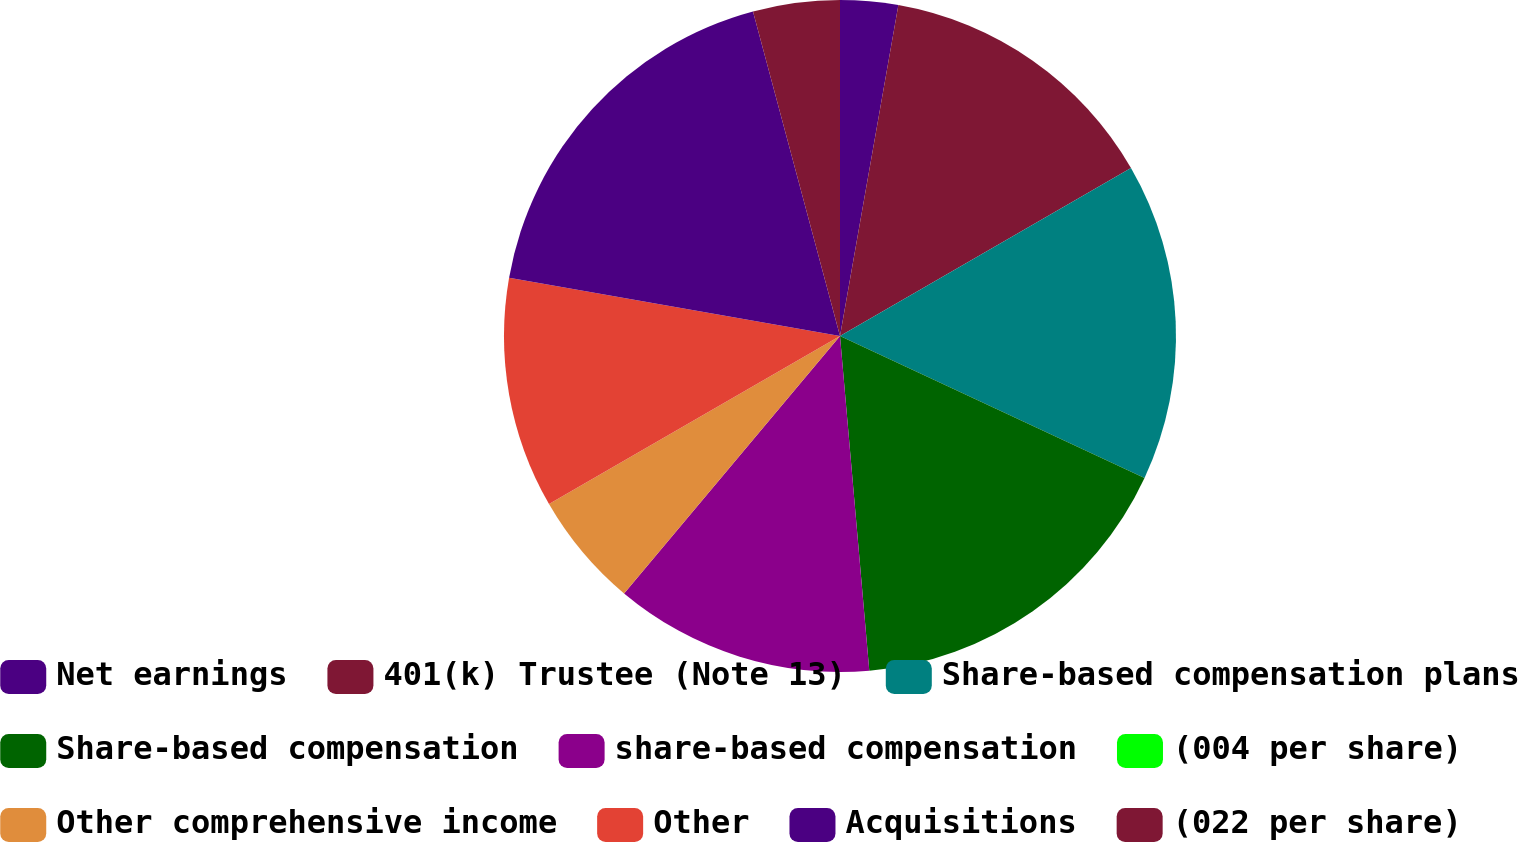Convert chart. <chart><loc_0><loc_0><loc_500><loc_500><pie_chart><fcel>Net earnings<fcel>401(k) Trustee (Note 13)<fcel>Share-based compensation plans<fcel>Share-based compensation<fcel>share-based compensation<fcel>(004 per share)<fcel>Other comprehensive income<fcel>Other<fcel>Acquisitions<fcel>(022 per share)<nl><fcel>2.78%<fcel>13.89%<fcel>15.28%<fcel>16.67%<fcel>12.5%<fcel>0.0%<fcel>5.56%<fcel>11.11%<fcel>18.06%<fcel>4.17%<nl></chart> 